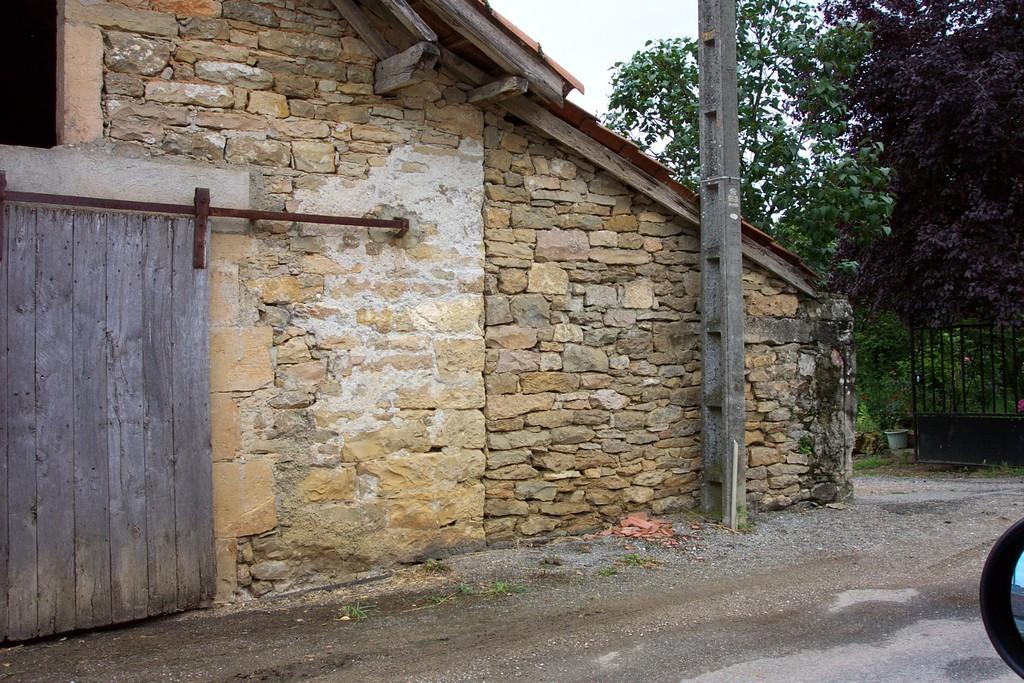What type of structure is visible in the image? There is a house in the image. What other objects can be seen in the image? There is a pole, trees, plants, and a gate visible in the image. What is the background of the image? The sky is visible in the image. What is the setting of the image? The image features a house, trees, plants, and a gate, suggesting it might be a residential area. What else is present in the image? A road is present in the image. How many horses are visible in the image? There are no horses present in the image. What type of wire is used to hold up the time in the image? There is no wire or time present in the image. 